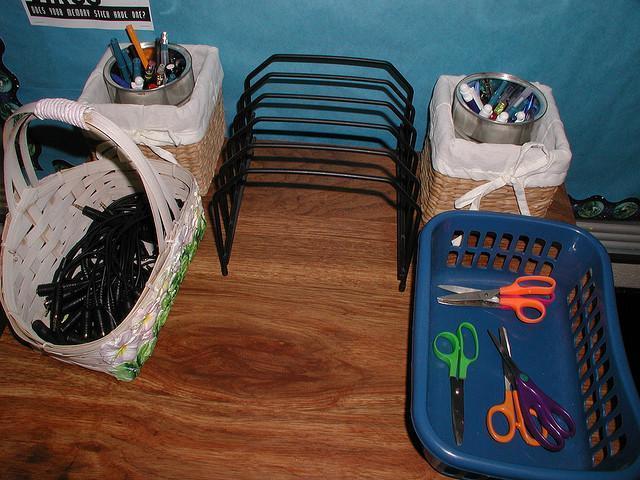How many pairs of scissors are pictured?
Give a very brief answer. 4. How many baskets are pictured?
Give a very brief answer. 4. How many dining tables are in the picture?
Give a very brief answer. 1. How many scissors are visible?
Give a very brief answer. 4. How many cars are there?
Give a very brief answer. 0. 